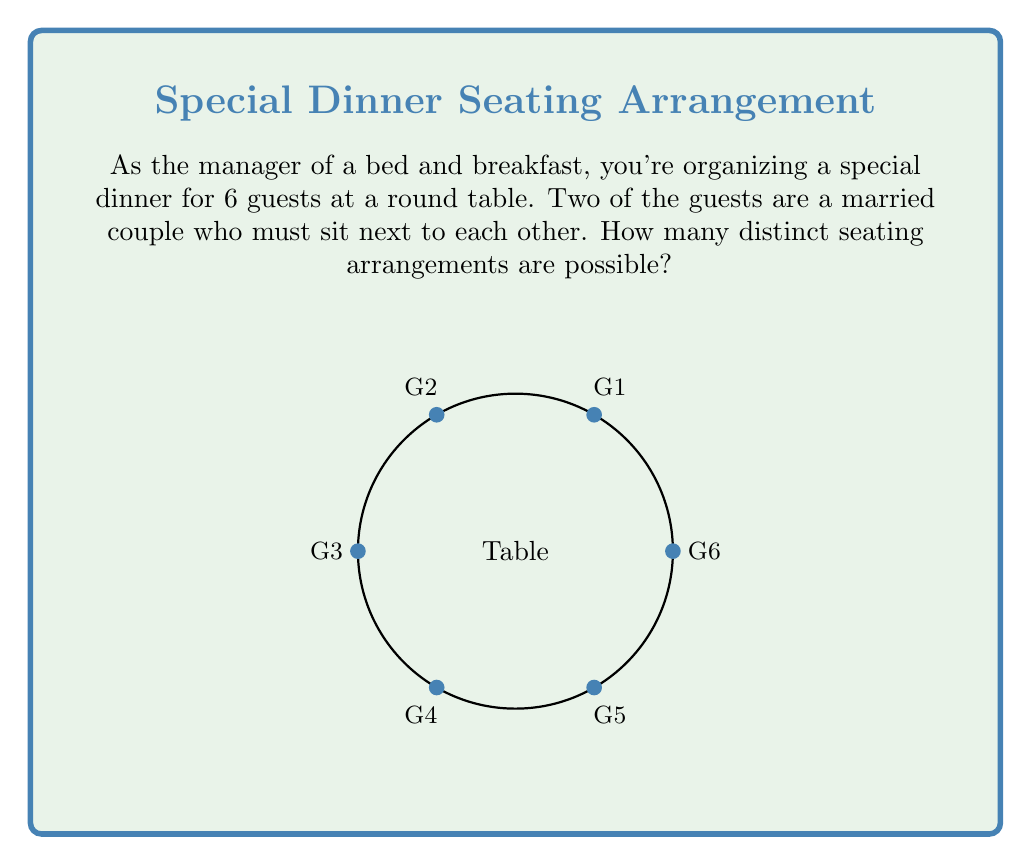What is the answer to this math problem? Let's approach this step-by-step using group theory:

1) First, consider the married couple as a single unit. This reduces our problem to arranging 5 units around the table (the couple and 4 individual guests).

2) The number of ways to arrange n distinct objects in a circle is $(n-1)!$. This is because we can fix one object and permute the rest.

3) So, for 5 units, we have $4! = 24$ arrangements.

4) However, for each of these arrangements, the married couple can swap their positions. This doubles our possibilities.

5) Therefore, the total number of arrangements is:

   $$24 \times 2 = 48$$

6) We can also arrive at this using the orbit-stabilizer theorem:

   Let $G$ be the group of rotations and reflections of a regular hexagon (order 12).
   Let $X$ be the set of all possible seating arrangements.
   
   The orbit of any seating arrangement under $G$ has size 12.
   
   By the orbit-stabilizer theorem:
   $$|X| \times 12 = |G| \times |X/G| = 12 \times |X/G|$$

   $|X/G|$ is the number of orbits, which is our answer.

   $$|X| = |X/G| = 48$$

Thus, there are 48 distinct seating arrangements.
Answer: 48 arrangements 